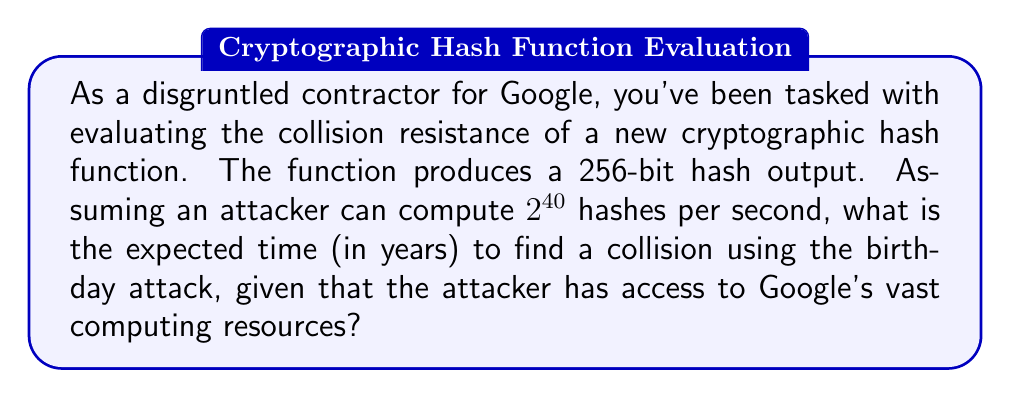Solve this math problem. To solve this problem, we'll follow these steps:

1) The birthday attack exploits the birthday paradox to find collisions more efficiently than brute force.

2) For a hash function with an n-bit output, the expected number of hashes needed to find a collision is approximately $\sqrt{2^n}$ = $2^{n/2}$.

3) In this case, n = 256, so we need approximately $2^{256/2} = 2^{128}$ hashes.

4) The attacker can compute $2^{40}$ hashes per second.

5) To find the time needed:
   $$\text{Time (in seconds)} = \frac{2^{128}}{2^{40}} = 2^{88}$$

6) Convert seconds to years:
   $$\text{Years} = \frac{2^{88}}{60 \times 60 \times 24 \times 365.25}$$

7) Simplify:
   $$\text{Years} \approx \frac{2^{88}}{2^{25.24}} = 2^{62.76} \approx 7.75 \times 10^{18}$$

This extremely large number demonstrates the strong collision resistance of a 256-bit hash function, even against an attacker with significant computational resources.
Answer: $7.75 \times 10^{18}$ years 